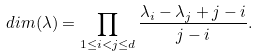<formula> <loc_0><loc_0><loc_500><loc_500>d i m ( \lambda ) = \prod _ { 1 \leq i < j \leq d } \frac { \lambda _ { i } - \lambda _ { j } + j - i } { j - i } .</formula> 